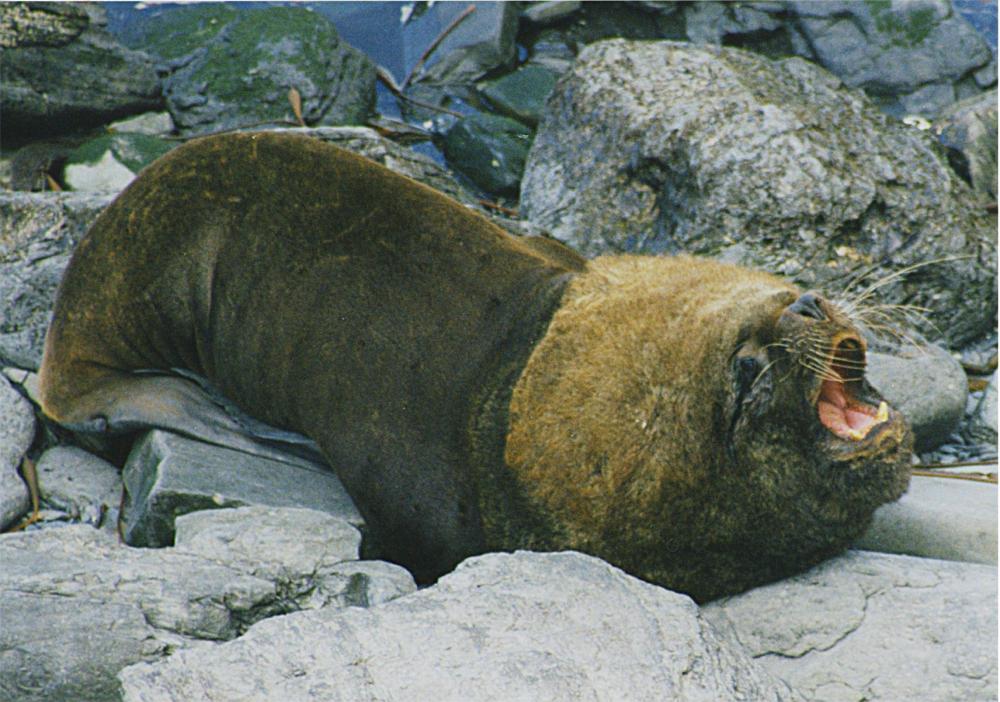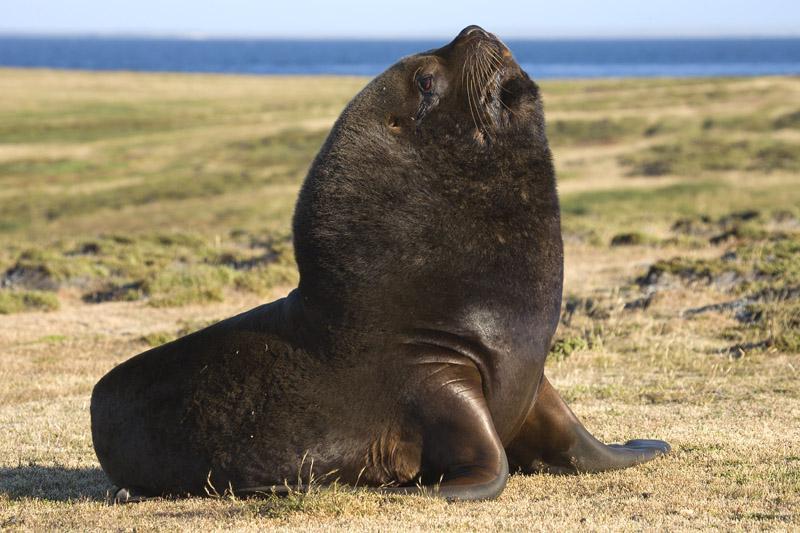The first image is the image on the left, the second image is the image on the right. Analyze the images presented: Is the assertion "There is 1 male seal next to 1 female." valid? Answer yes or no. No. The first image is the image on the left, the second image is the image on the right. Evaluate the accuracy of this statement regarding the images: "One image shows exactly two seals, which are of different sizes.". Is it true? Answer yes or no. No. The first image is the image on the left, the second image is the image on the right. For the images shown, is this caption "One of the images shows exactly two sea lions." true? Answer yes or no. No. 